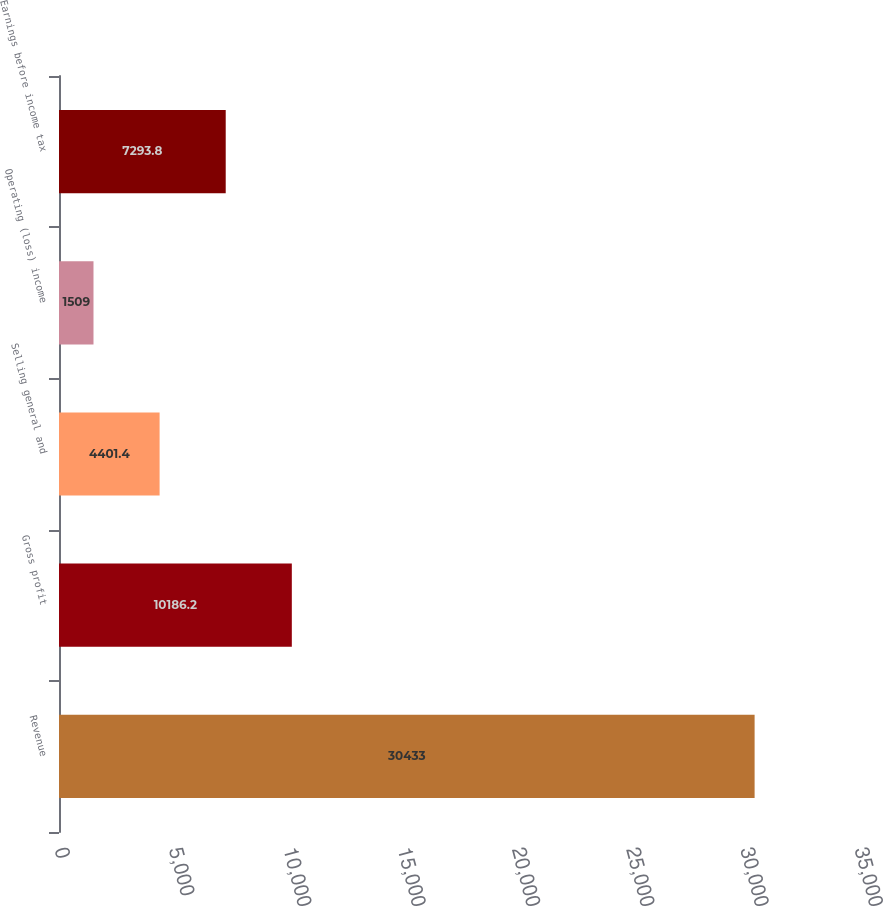Convert chart. <chart><loc_0><loc_0><loc_500><loc_500><bar_chart><fcel>Revenue<fcel>Gross profit<fcel>Selling general and<fcel>Operating (loss) income<fcel>Earnings before income tax<nl><fcel>30433<fcel>10186.2<fcel>4401.4<fcel>1509<fcel>7293.8<nl></chart> 